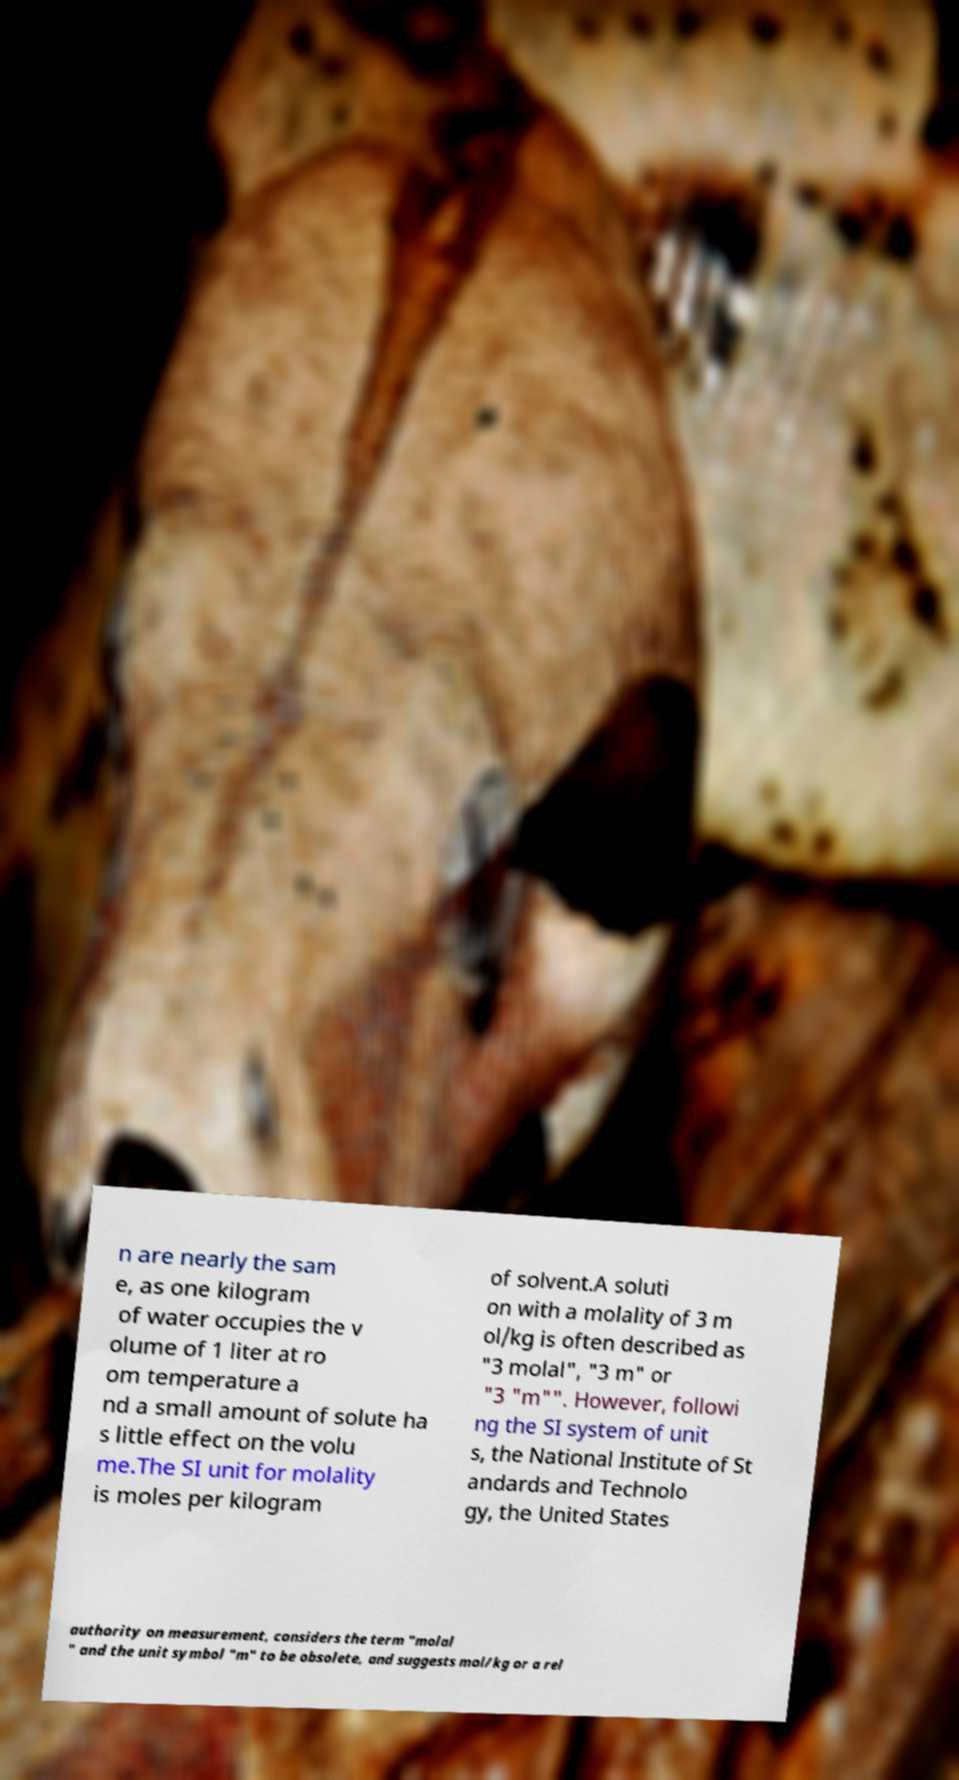I need the written content from this picture converted into text. Can you do that? n are nearly the sam e, as one kilogram of water occupies the v olume of 1 liter at ro om temperature a nd a small amount of solute ha s little effect on the volu me.The SI unit for molality is moles per kilogram of solvent.A soluti on with a molality of 3 m ol/kg is often described as "3 molal", "3 m" or "3 "m"". However, followi ng the SI system of unit s, the National Institute of St andards and Technolo gy, the United States authority on measurement, considers the term "molal " and the unit symbol "m" to be obsolete, and suggests mol/kg or a rel 